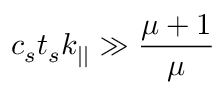<formula> <loc_0><loc_0><loc_500><loc_500>c _ { s } t _ { s } k _ { | | } \gg \frac { \mu + 1 } \mu</formula> 